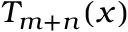<formula> <loc_0><loc_0><loc_500><loc_500>T _ { m + n } ( x )</formula> 